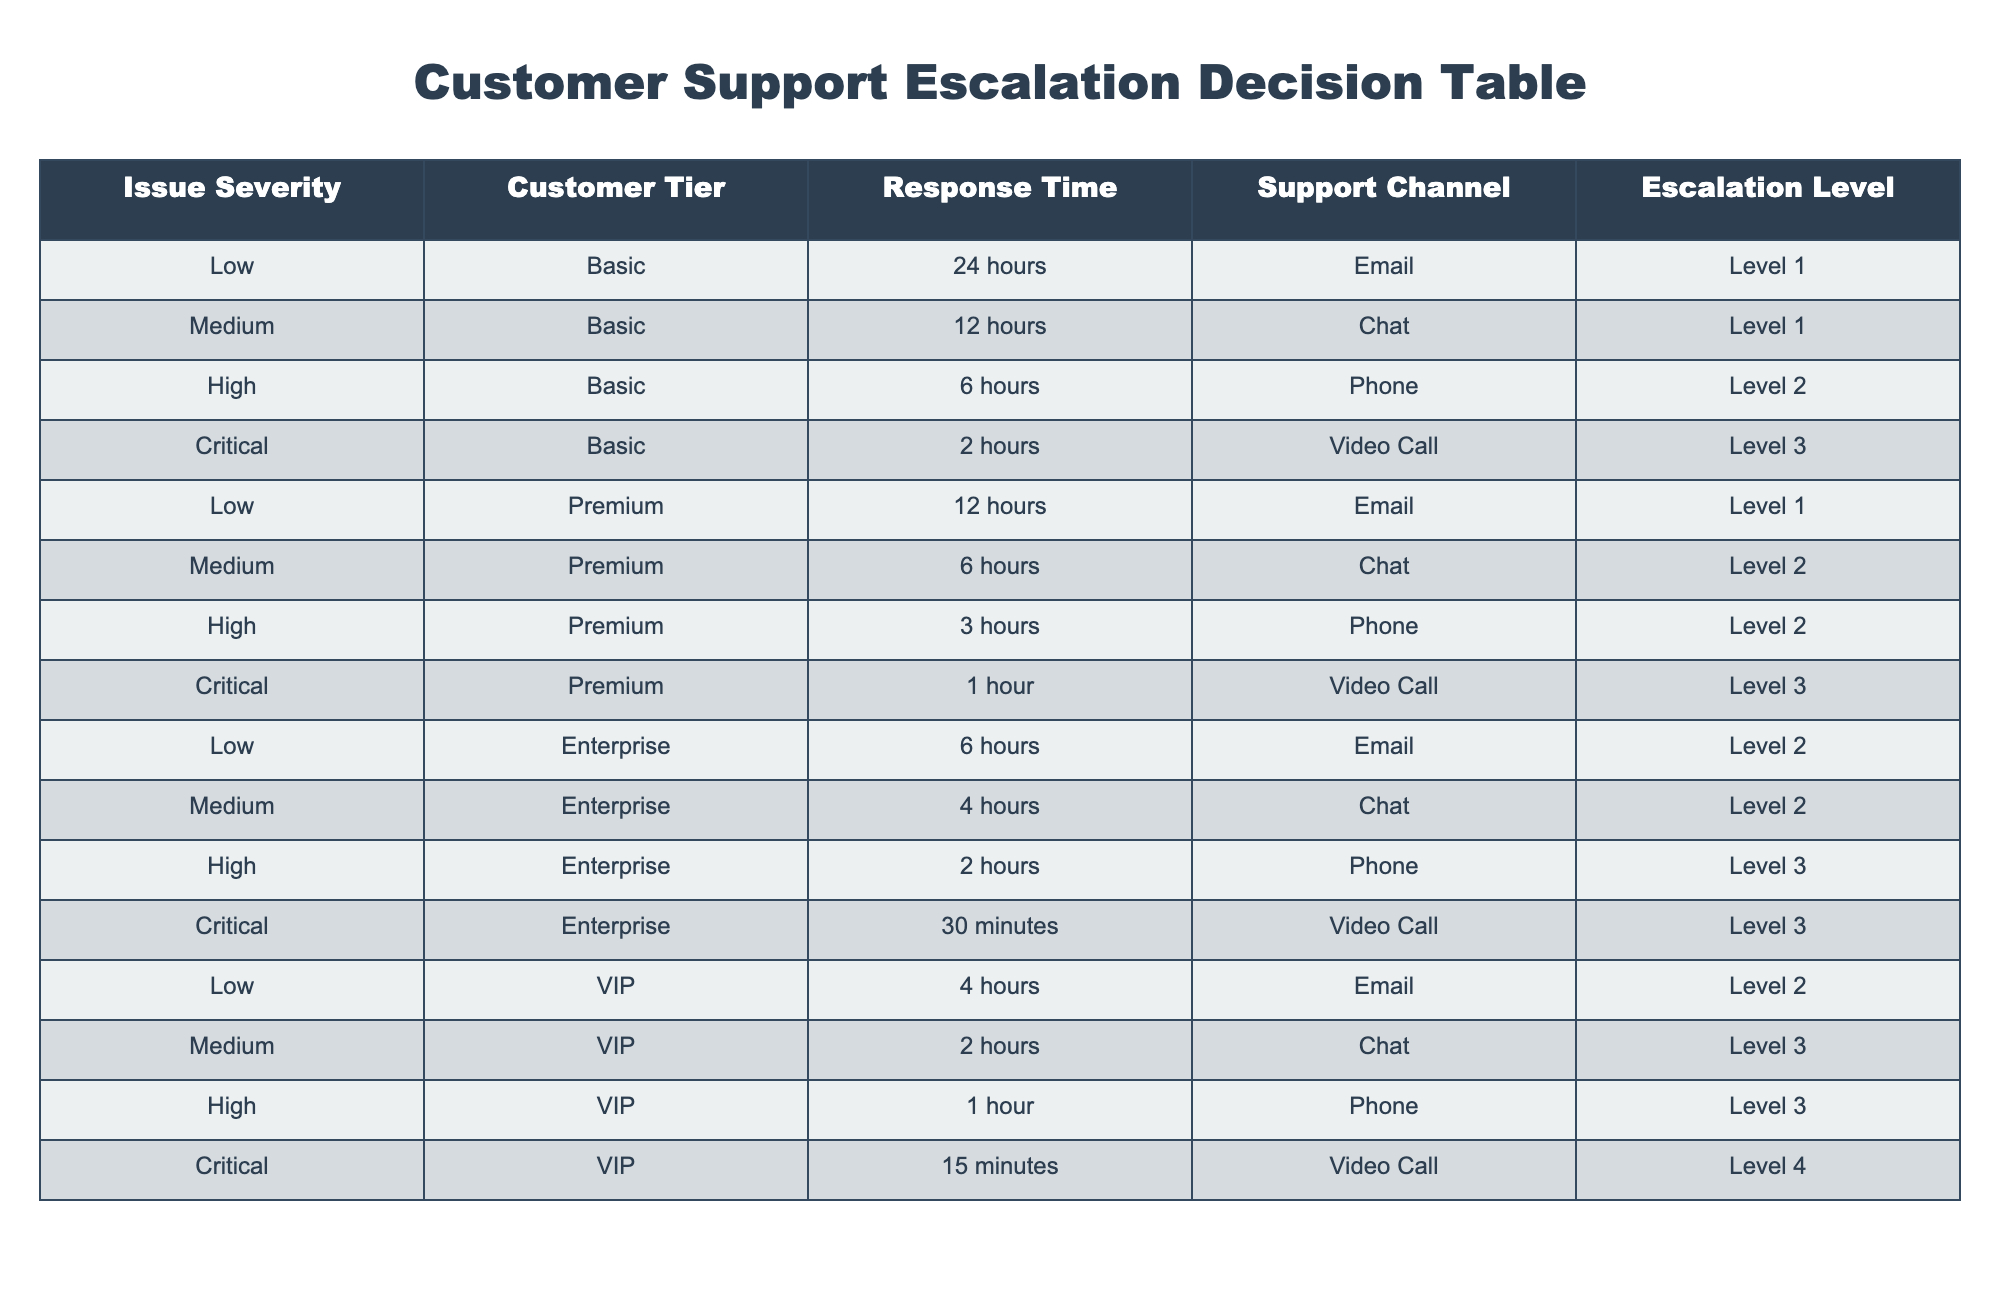What is the escalation level for a High severity issue reported by a Basic tier customer? In the table, we find the row where the Issue Severity is "High" and the Customer Tier is "Basic". According to the table, this corresponds to "Level 2".
Answer: Level 2 What is the response time for a Critical issue in the Premium tier? The table shows that for a Critical issue (Severity) in the Premium tier (Customer Tier), the corresponding Response Time is "1 hour".
Answer: 1 hour How many escalation levels are there for the Low severity category across all customer tiers? The escalation levels for Low severity issues based on the table are Level 1 for Basic, Level 1 for Premium, Level 2 for Enterprise, and Level 2 for VIP. This totals to 3 unique levels: Level 1 and Level 2.
Answer: 3 Is the response time for a Medium severity issue in VIP shorter than that in Basic? For Medium severity issues, the Response Time in the VIP tier is "2 hours", while in the Basic tier it is "12 hours". Since 2 hours is shorter than 12 hours, the answer is yes.
Answer: Yes What is the maximum response time for Low severity issues across all customer tiers? By examining the rows for Low severity across all tiers: Basic is 24 hours, Premium is 12 hours, Enterprise is 6 hours, and VIP is 4 hours. The maximum of these is 24 hours (from the Basic tier).
Answer: 24 hours If a Critical issue is reported via a Phone call by an Enterprise customer, what should the escalation level be? Referring to the table, for a Critical issue (Severity) and Enterprise (Tier) the escalation level must be Level 3. Since the method of reporting (Phone) does not apply, we only consider Severity and Tier.
Answer: Level 3 What is the average response time for Medium severity issues across all customer tiers? For Medium severity, the response times are: 12 hours (Basic), 6 hours (Premium), 4 hours (Enterprise), and 2 hours (VIP). Summing these gives 12 + 6 + 4 + 2 = 24 hours, and since there are 4 tiers, the average is 24 / 4 = 6 hours.
Answer: 6 hours Are all Critical issue escalations at Level 3 or higher? Reviewing the table for Critical issues, we see that all listed tiers (Basic, Premium, Enterprise, VIP) have escalation levels that are Level 3 or higher (Level 3 and Level 4). Therefore, the answer is yes.
Answer: Yes 